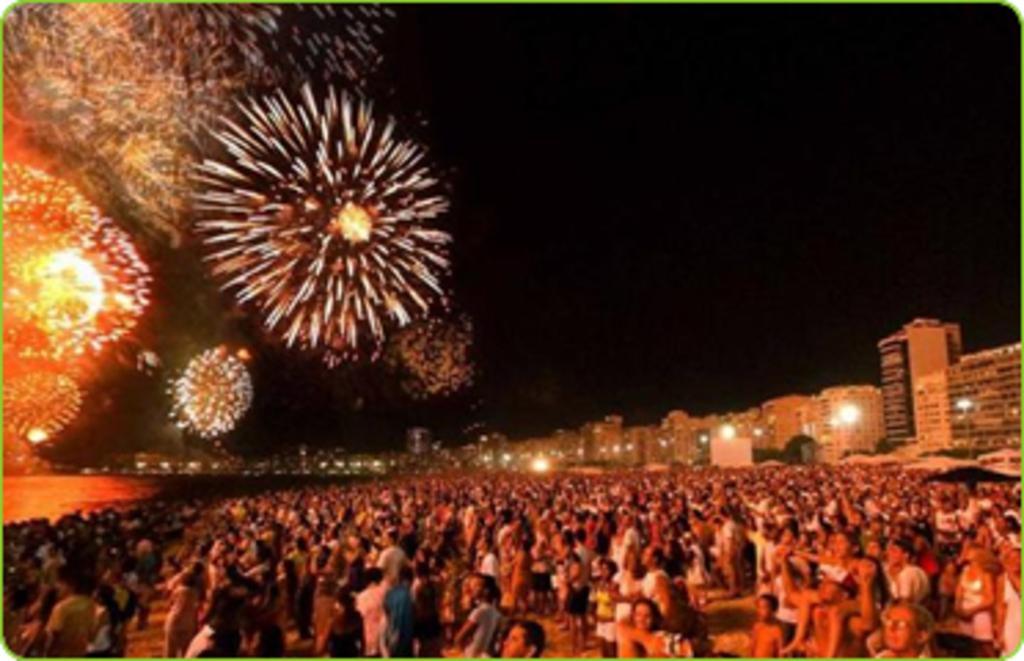In one or two sentences, can you explain what this image depicts? This is an edited picture. This is the picture of a city. In this image there are buildings and trees and there are group of people standing. On the left side of the image there is water. At the top there are fireworks in the sky. 